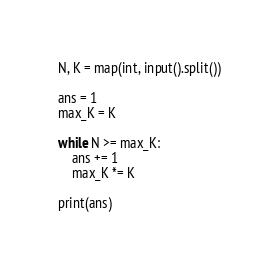<code> <loc_0><loc_0><loc_500><loc_500><_Python_>N, K = map(int, input().split())

ans = 1
max_K = K

while N >= max_K:
    ans += 1
    max_K *= K

print(ans)</code> 